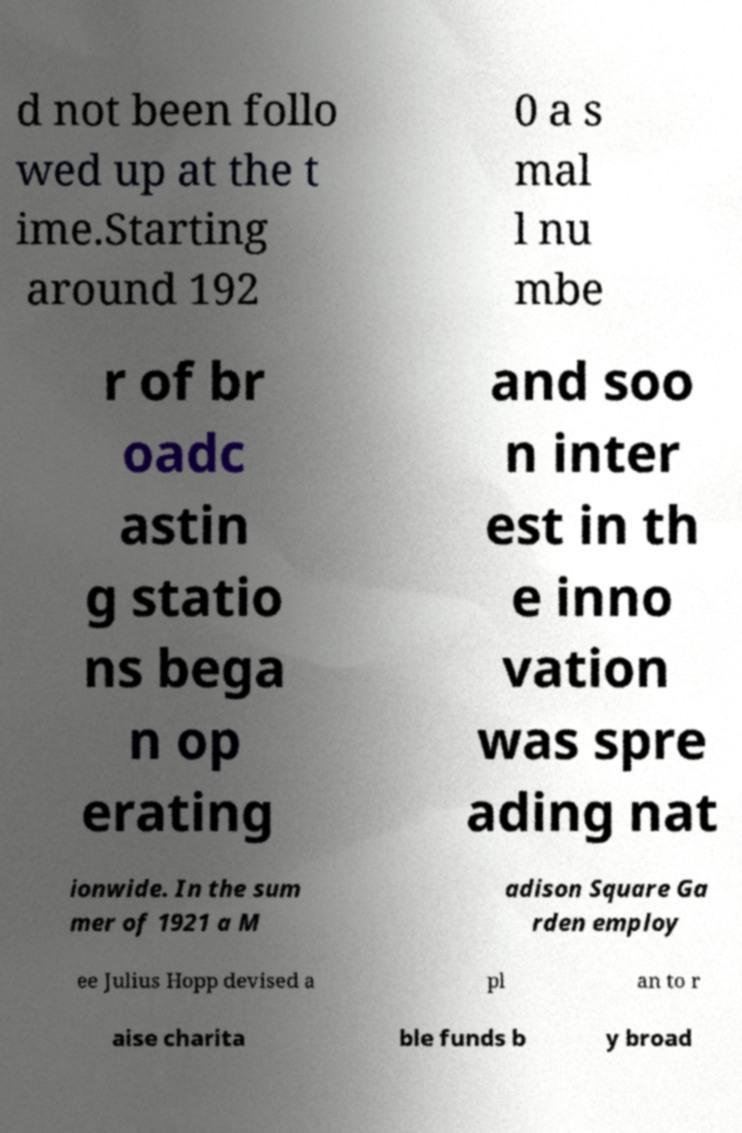What messages or text are displayed in this image? I need them in a readable, typed format. d not been follo wed up at the t ime.Starting around 192 0 a s mal l nu mbe r of br oadc astin g statio ns bega n op erating and soo n inter est in th e inno vation was spre ading nat ionwide. In the sum mer of 1921 a M adison Square Ga rden employ ee Julius Hopp devised a pl an to r aise charita ble funds b y broad 